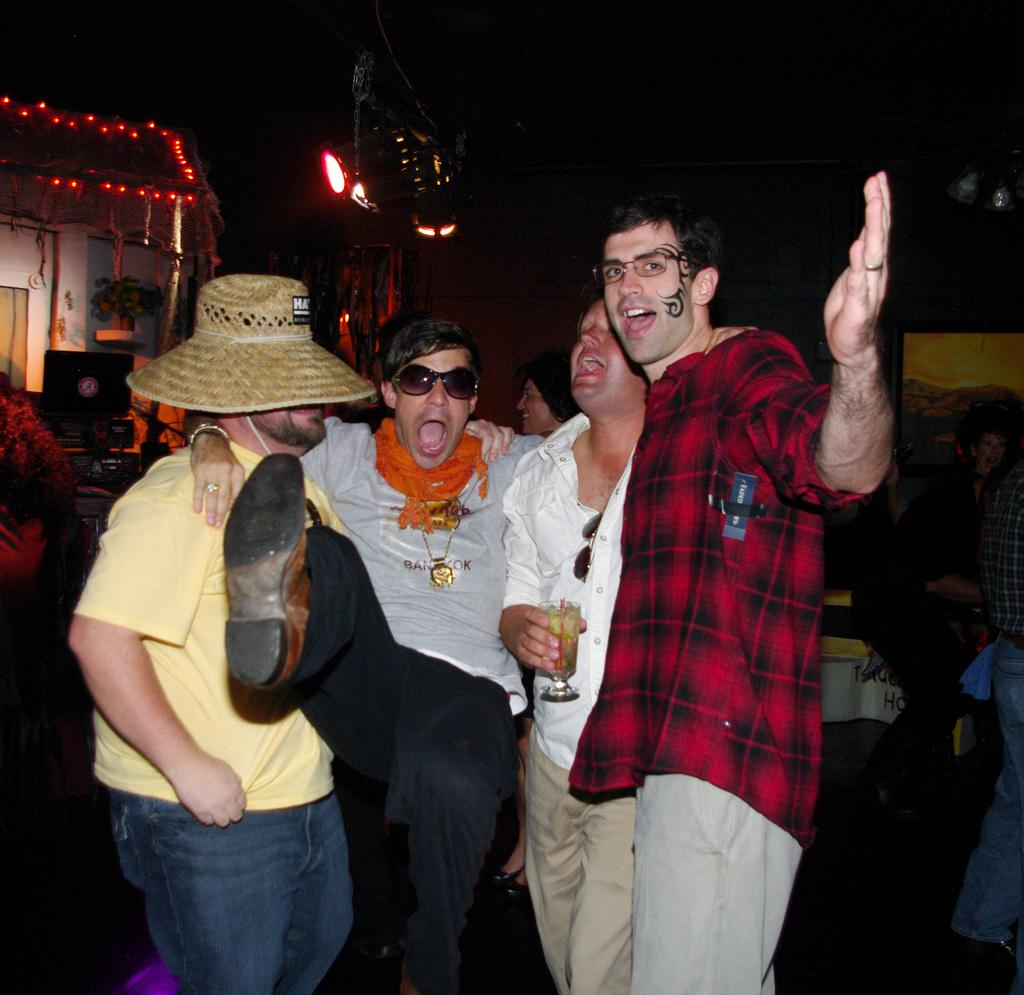How many persons are visible in the image? There are persons in the image. What type of object can be seen in the image? There is a glass object in the image. Can you describe the other objects in the image? There are other objects in the image, but their specific details are not mentioned in the provided facts. What can be seen in the background of the image? In the background of the image, there are persons, lights, a monitor, and other objects. What decision is being made by the can in the image? There is no can present in the image, so it is not possible to determine any decisions being made by a can. 